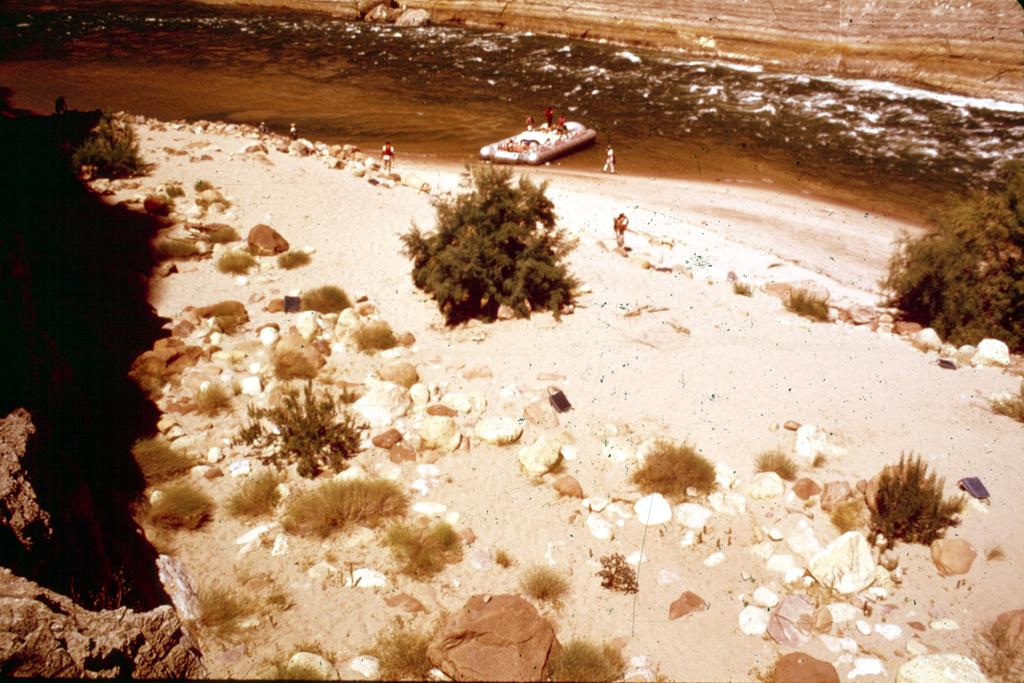What type of vegetation can be seen in the image? There are trees in the image. What is the color of the trees? The trees are green. What can be seen in the background of the image? There is a boat in the background of the image. What are the persons in the boat wearing? The persons are wearing red shirts. What type of terrain is visible in the image? There are stones visible in the image. What type of crook can be seen in the image? There is no crook present in the image. What is the box used for in the image? There is no box present in the image. 